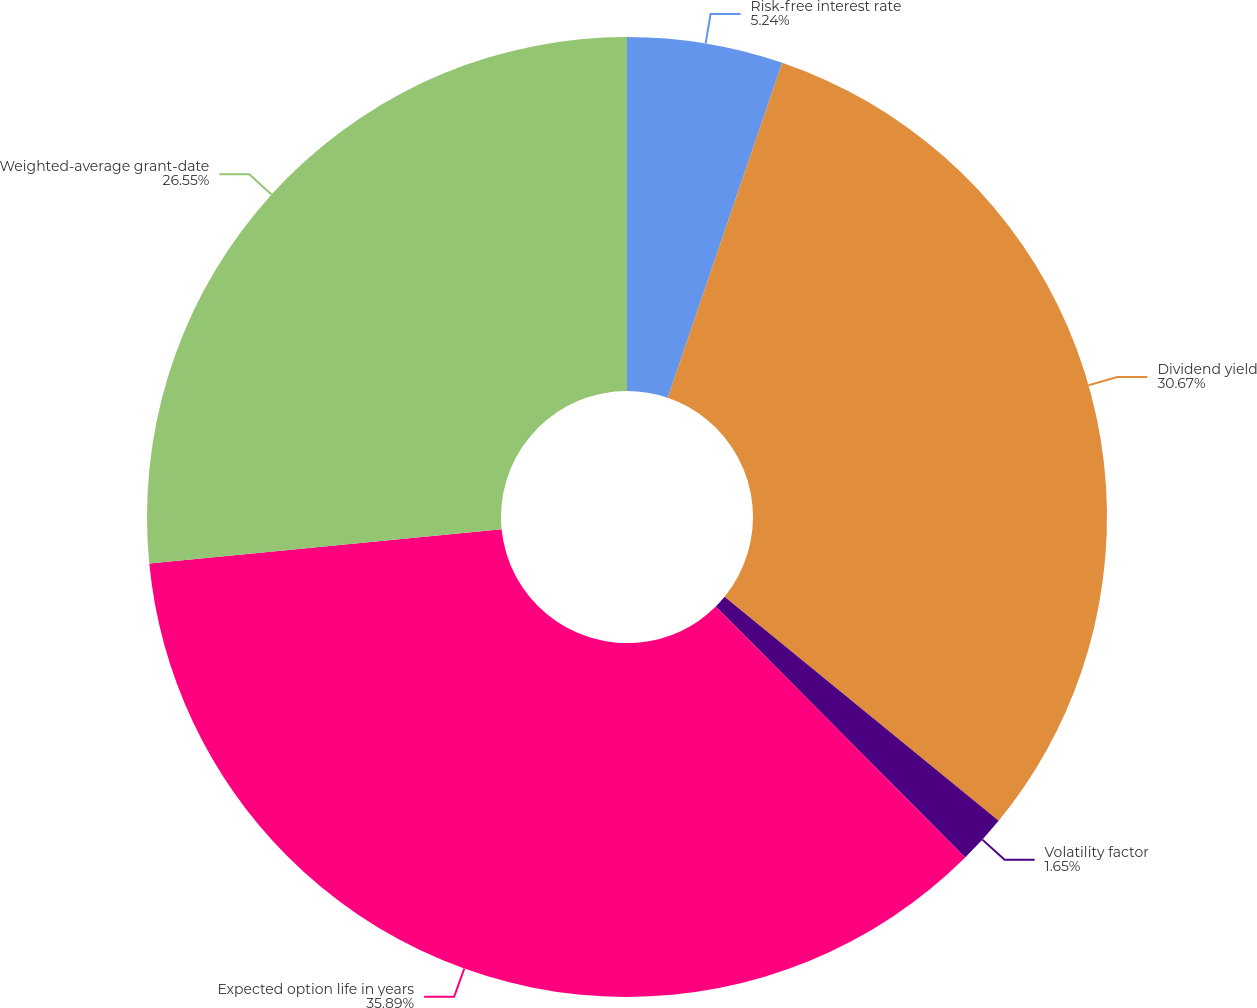Convert chart to OTSL. <chart><loc_0><loc_0><loc_500><loc_500><pie_chart><fcel>Risk-free interest rate<fcel>Dividend yield<fcel>Volatility factor<fcel>Expected option life in years<fcel>Weighted-average grant-date<nl><fcel>5.24%<fcel>30.67%<fcel>1.65%<fcel>35.9%<fcel>26.55%<nl></chart> 